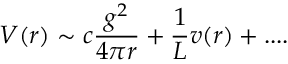<formula> <loc_0><loc_0><loc_500><loc_500>V ( r ) \sim c \frac { g ^ { 2 } } { 4 \pi r } + \frac { 1 } { L } v ( r ) + \cdots</formula> 